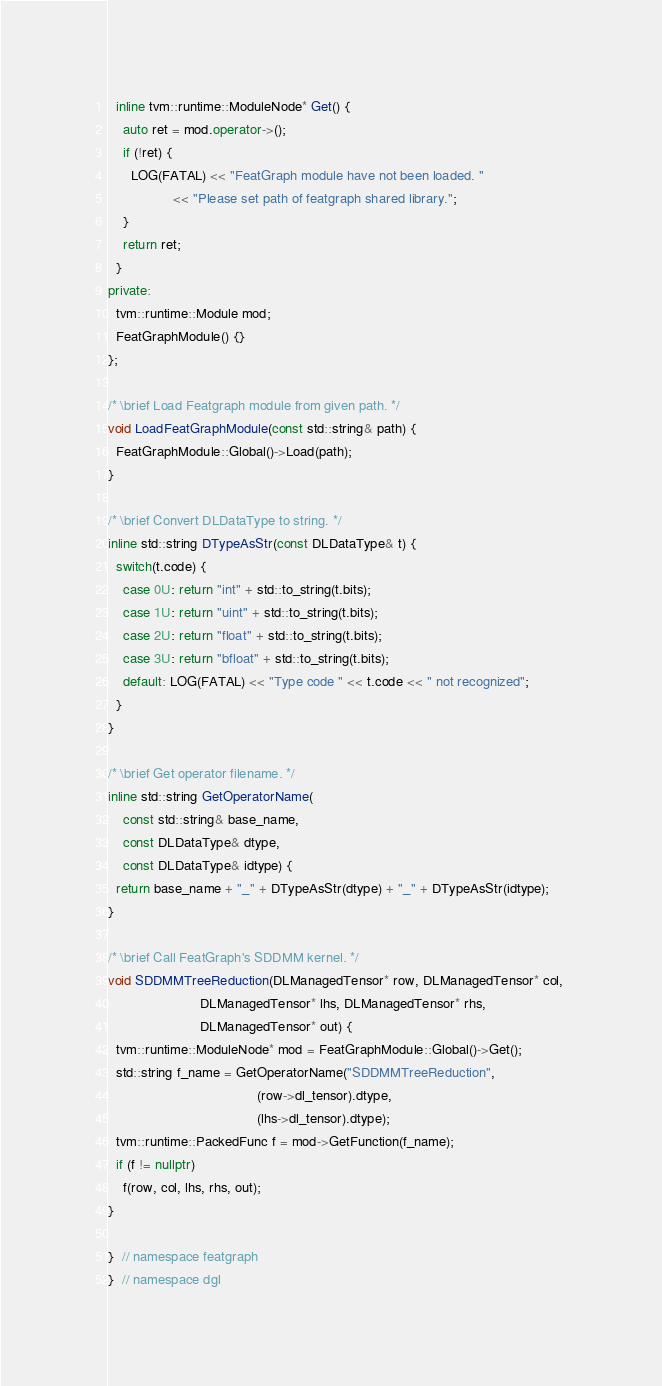Convert code to text. <code><loc_0><loc_0><loc_500><loc_500><_C++_>
  inline tvm::runtime::ModuleNode* Get() {
    auto ret = mod.operator->();
    if (!ret) {
      LOG(FATAL) << "FeatGraph module have not been loaded. "
                 << "Please set path of featgraph shared library.";
    }
    return ret;
  }
private:
  tvm::runtime::Module mod;
  FeatGraphModule() {}
};

/* \brief Load Featgraph module from given path. */
void LoadFeatGraphModule(const std::string& path) {
  FeatGraphModule::Global()->Load(path);
}

/* \brief Convert DLDataType to string. */
inline std::string DTypeAsStr(const DLDataType& t) {
  switch(t.code) {
    case 0U: return "int" + std::to_string(t.bits);
    case 1U: return "uint" + std::to_string(t.bits);
    case 2U: return "float" + std::to_string(t.bits);
    case 3U: return "bfloat" + std::to_string(t.bits);
    default: LOG(FATAL) << "Type code " << t.code << " not recognized";
  }
}

/* \brief Get operator filename. */
inline std::string GetOperatorName(
    const std::string& base_name,
    const DLDataType& dtype,
    const DLDataType& idtype) {
  return base_name + "_" + DTypeAsStr(dtype) + "_" + DTypeAsStr(idtype);
}

/* \brief Call FeatGraph's SDDMM kernel. */
void SDDMMTreeReduction(DLManagedTensor* row, DLManagedTensor* col, 
                        DLManagedTensor* lhs, DLManagedTensor* rhs, 
                        DLManagedTensor* out) {
  tvm::runtime::ModuleNode* mod = FeatGraphModule::Global()->Get();
  std::string f_name = GetOperatorName("SDDMMTreeReduction",
                                       (row->dl_tensor).dtype,
                                       (lhs->dl_tensor).dtype);
  tvm::runtime::PackedFunc f = mod->GetFunction(f_name);
  if (f != nullptr)
    f(row, col, lhs, rhs, out);
}

}  // namespace featgraph
}  // namespace dgl
</code> 